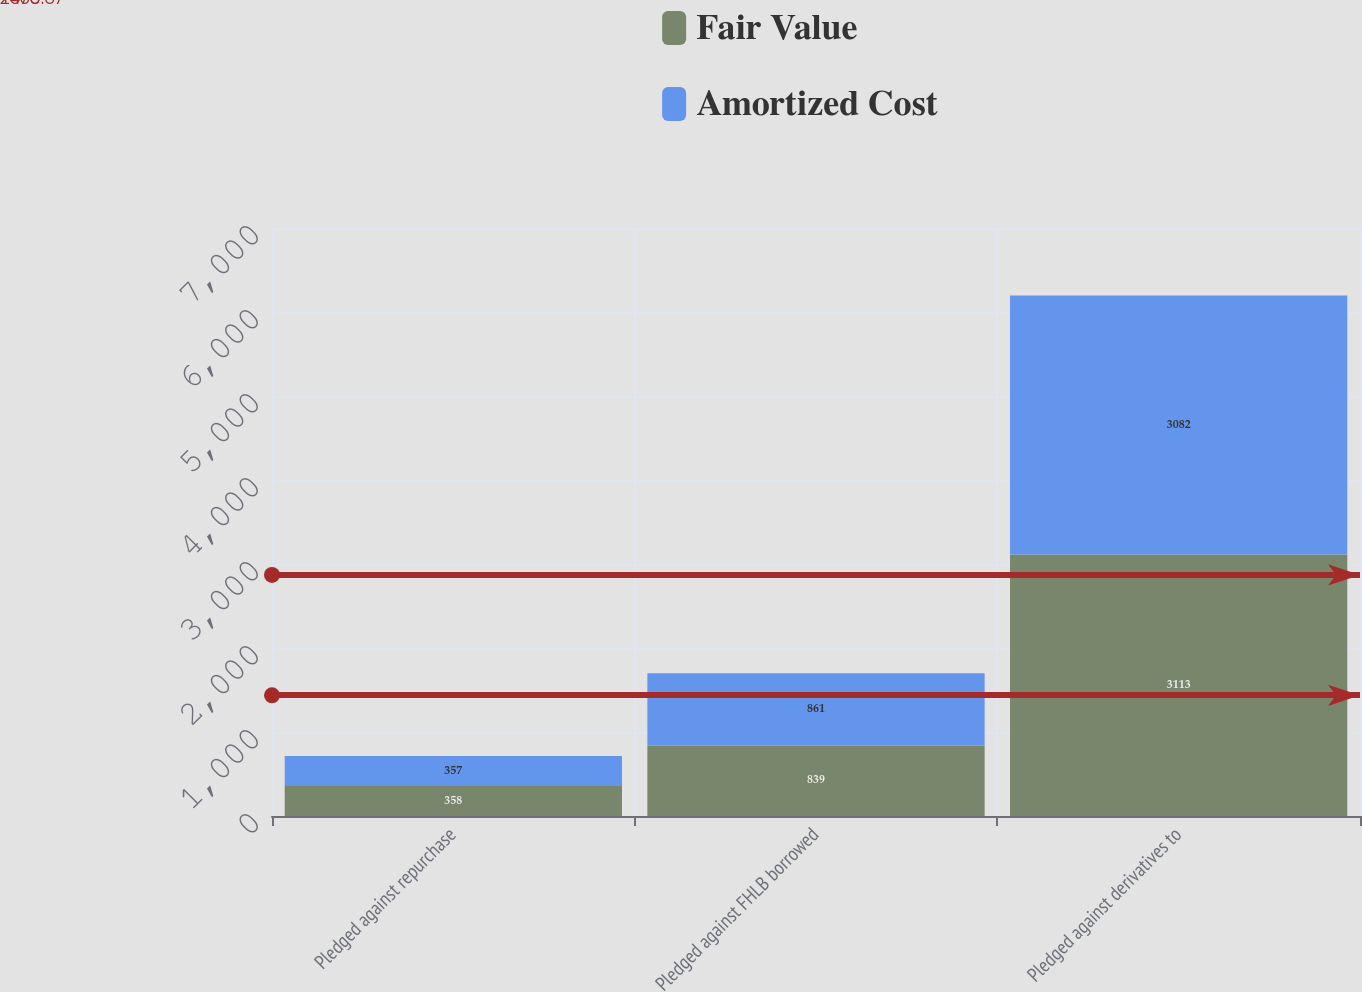Convert chart to OTSL. <chart><loc_0><loc_0><loc_500><loc_500><stacked_bar_chart><ecel><fcel>Pledged against repurchase<fcel>Pledged against FHLB borrowed<fcel>Pledged against derivatives to<nl><fcel>Fair Value<fcel>358<fcel>839<fcel>3113<nl><fcel>Amortized Cost<fcel>357<fcel>861<fcel>3082<nl></chart> 